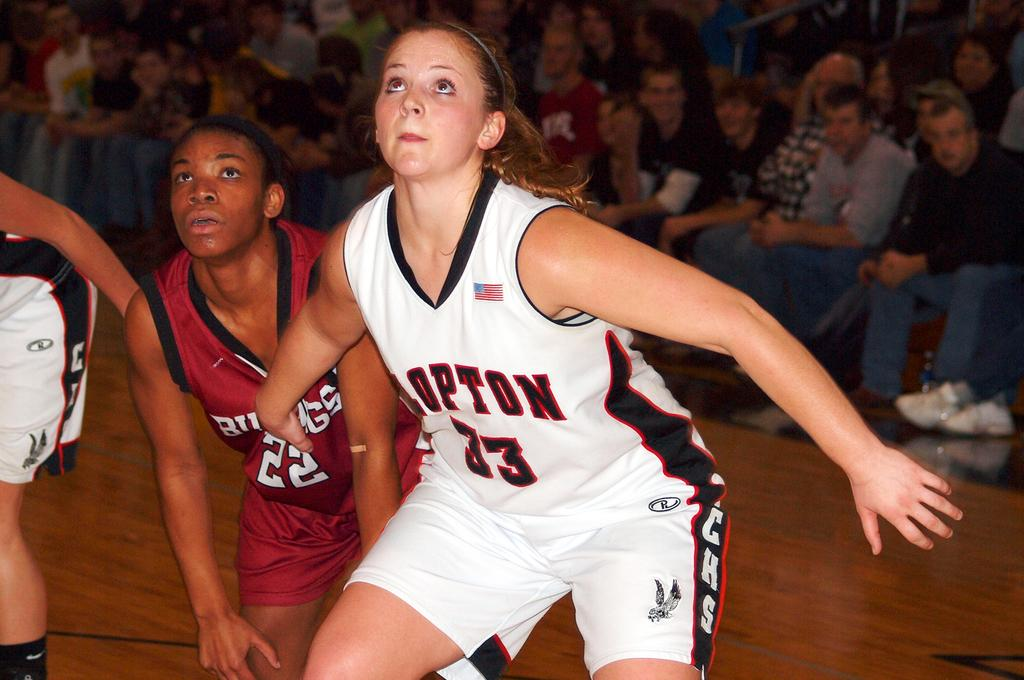<image>
Relay a brief, clear account of the picture shown. multiple women playing basketball in uniform and the audience watchin 